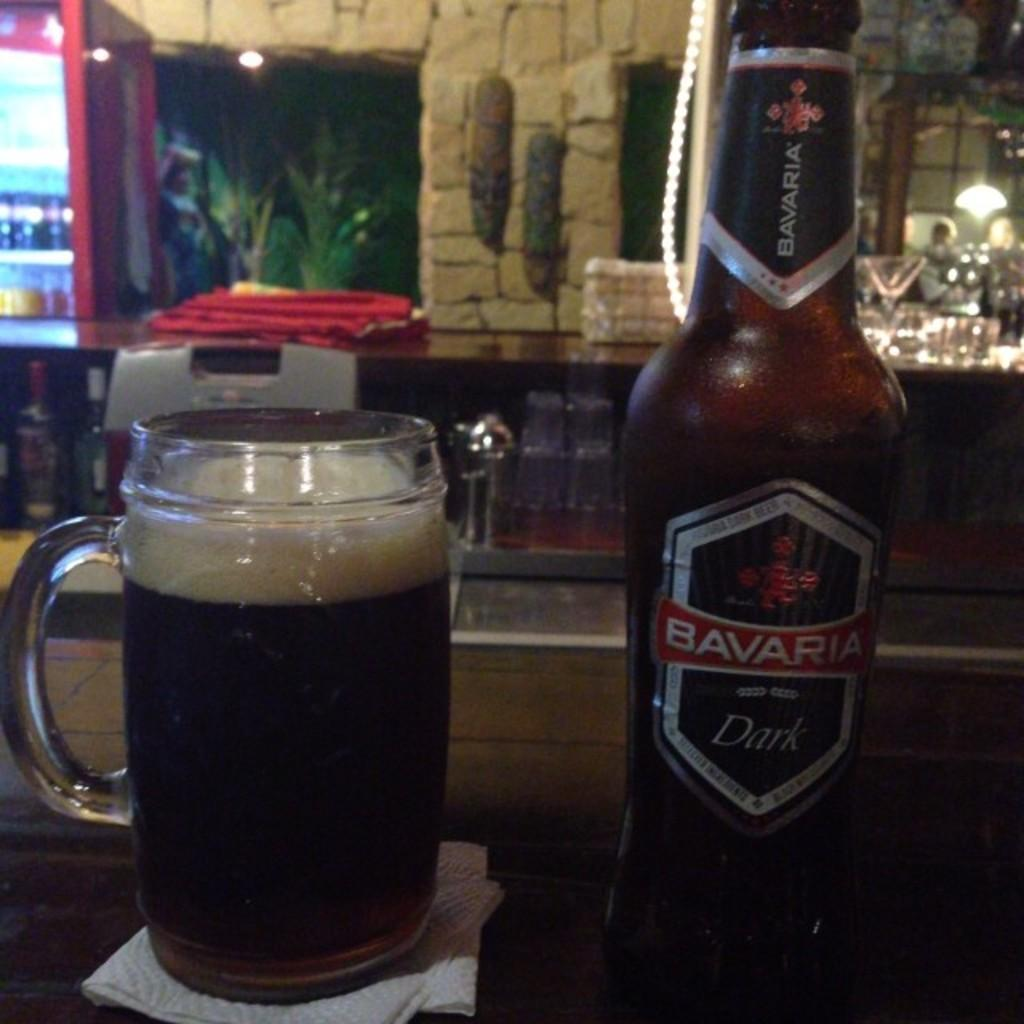<image>
Relay a brief, clear account of the picture shown. Cup of beer next to a Bavaria beer bottle. 